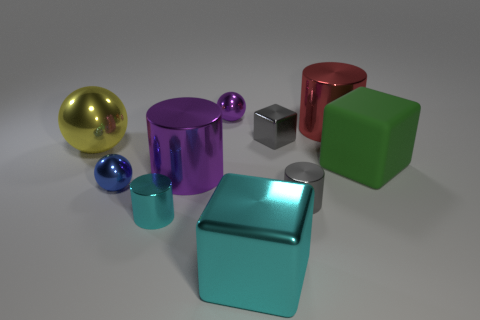Subtract all yellow blocks. Subtract all cyan balls. How many blocks are left? 3 Subtract all spheres. How many objects are left? 7 Add 10 red rubber things. How many red rubber things exist? 10 Subtract 1 green blocks. How many objects are left? 9 Subtract all large brown metallic cylinders. Subtract all blue metal things. How many objects are left? 9 Add 9 tiny blue balls. How many tiny blue balls are left? 10 